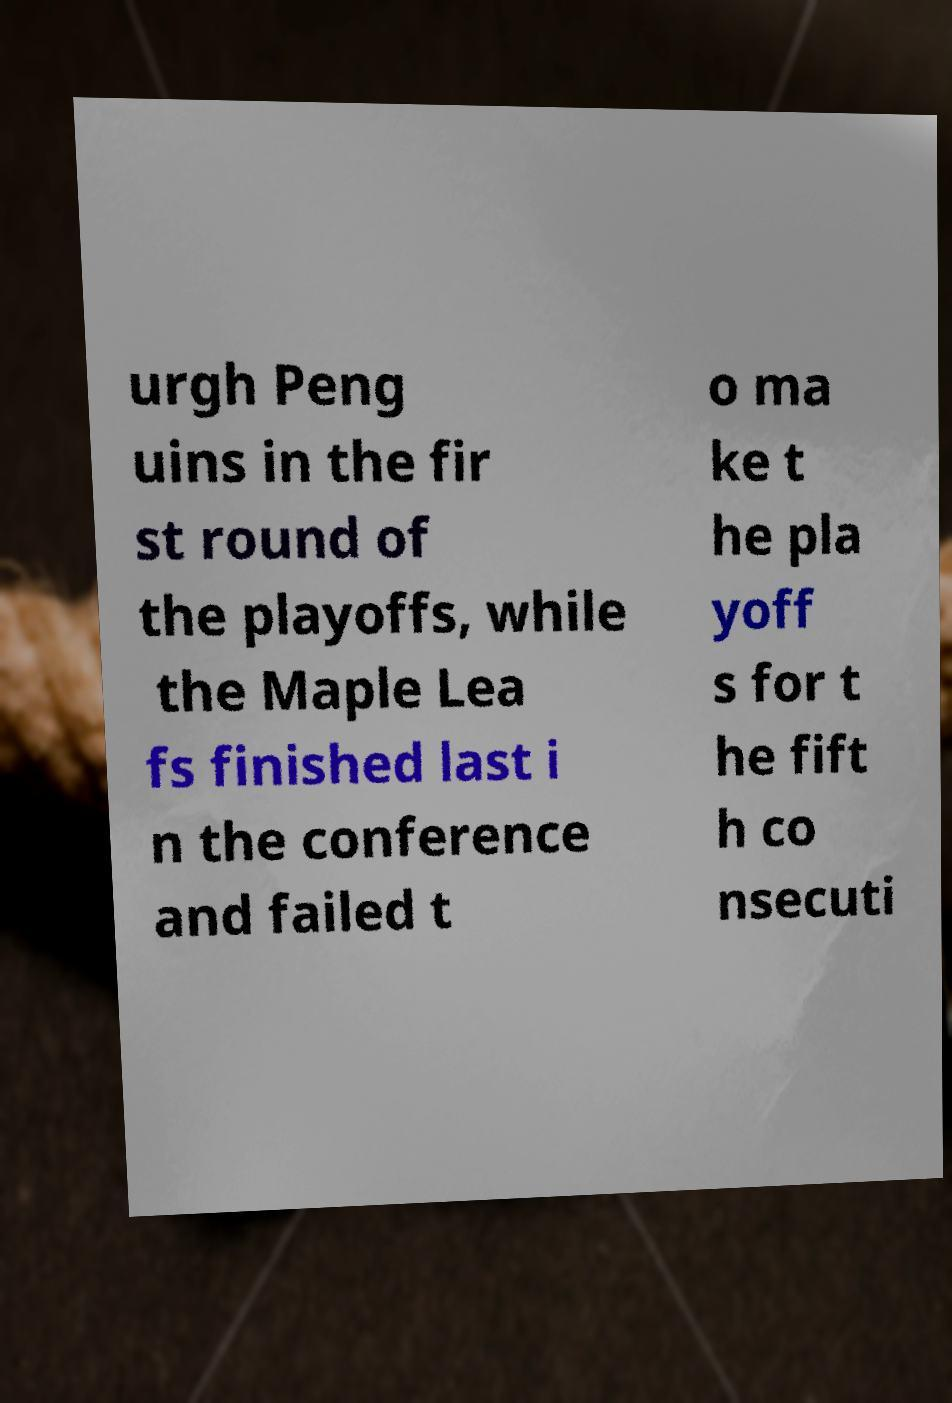Can you accurately transcribe the text from the provided image for me? urgh Peng uins in the fir st round of the playoffs, while the Maple Lea fs finished last i n the conference and failed t o ma ke t he pla yoff s for t he fift h co nsecuti 